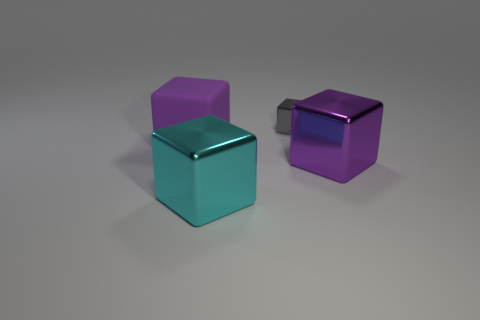How many big things have the same color as the matte block?
Provide a succinct answer. 1. The other object that is the same color as the large matte object is what size?
Offer a very short reply. Large. How many things are either shiny objects that are left of the gray metal block or purple objects right of the purple matte cube?
Provide a short and direct response. 2. There is a big cyan object that is the same shape as the small gray metal thing; what is its material?
Offer a terse response. Metal. What number of matte things are either big purple things or big brown blocks?
Provide a succinct answer. 1. The small object that is made of the same material as the large cyan object is what shape?
Your response must be concise. Cube. How many gray metal things have the same shape as the large purple matte object?
Provide a succinct answer. 1. There is a big purple thing that is in front of the big rubber object; is it the same shape as the matte object that is in front of the tiny metal object?
Offer a terse response. Yes. What number of things are shiny objects or purple blocks that are on the right side of the large matte thing?
Your response must be concise. 3. What is the shape of the metallic object that is the same color as the rubber block?
Provide a succinct answer. Cube. 